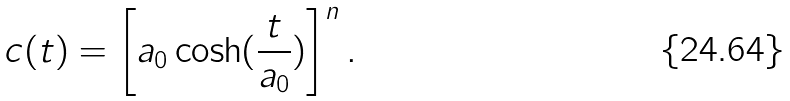Convert formula to latex. <formula><loc_0><loc_0><loc_500><loc_500>c ( t ) = \left [ a _ { 0 } \cosh ( \frac { t } { a _ { 0 } } ) \right ] ^ { n } .</formula> 